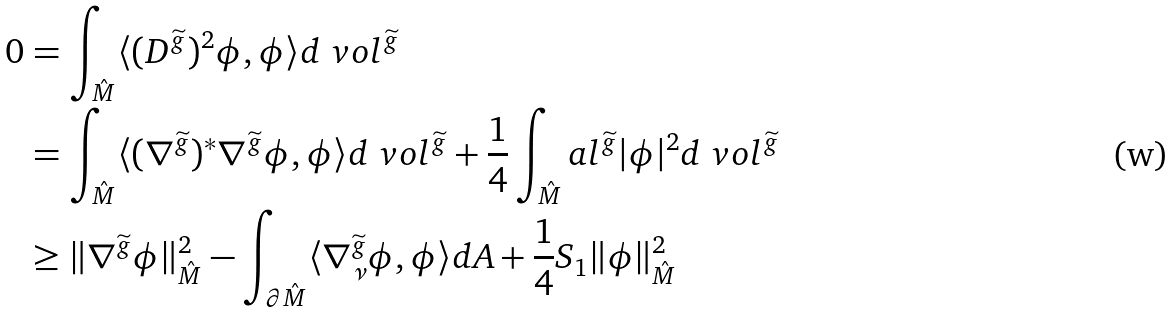Convert formula to latex. <formula><loc_0><loc_0><loc_500><loc_500>0 & = \int _ { \hat { M } } \langle ( D ^ { \widetilde { g } } ) ^ { 2 } \phi , \phi \rangle d \ v o l ^ { \widetilde { g } } \\ & = \int _ { \hat { M } } \langle ( \nabla ^ { \widetilde { g } } ) ^ { * } \nabla ^ { \widetilde { g } } \phi , \phi \rangle d \ v o l ^ { \widetilde { g } } + \frac { 1 } { 4 } \int _ { \hat { M } } a l ^ { \widetilde { g } } | \phi | ^ { 2 } d \ v o l ^ { \widetilde { g } } \\ & \geq \| \nabla ^ { \widetilde { g } } \phi \| ^ { 2 } _ { \hat { M } } - \int _ { \partial \hat { M } } \langle \nabla ^ { \widetilde { g } } _ { \nu } \phi , \phi \rangle d A + \frac { 1 } { 4 } S _ { 1 } \| \phi \| ^ { 2 } _ { \hat { M } }</formula> 